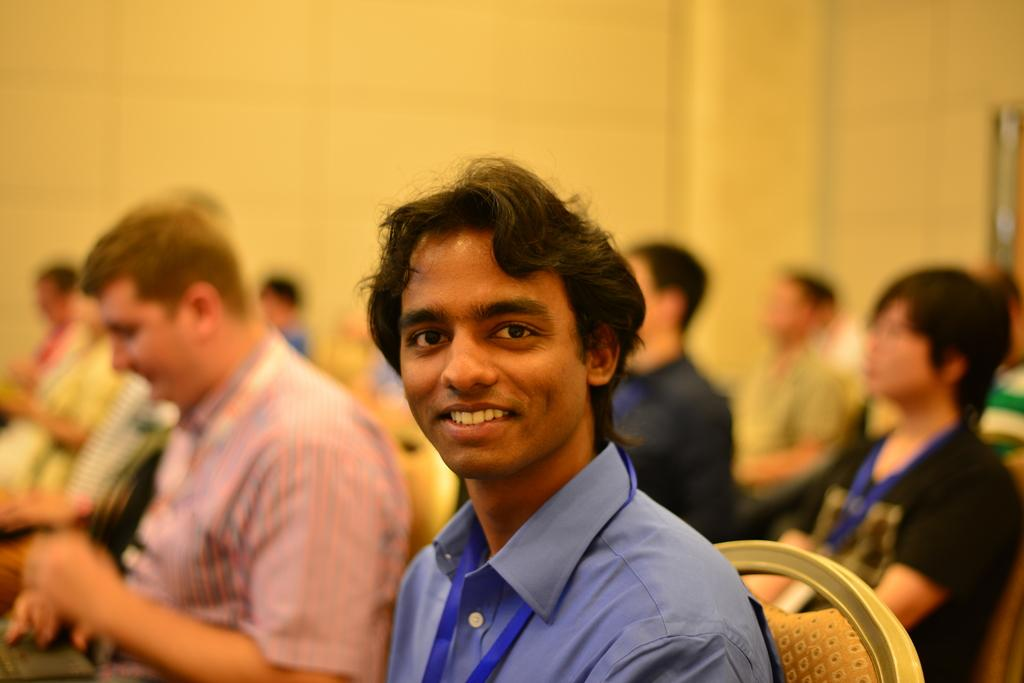Who is the main subject in the image? There is a man in the center of the image. What is the man doing in the image? The man is sitting on a chair. Can you describe the surroundings of the man? There are other people in the background of the image. What type of riddle can be heard being solved by the man in the image? There is no indication in the image that a riddle is being solved, nor is there any audio information provided. 